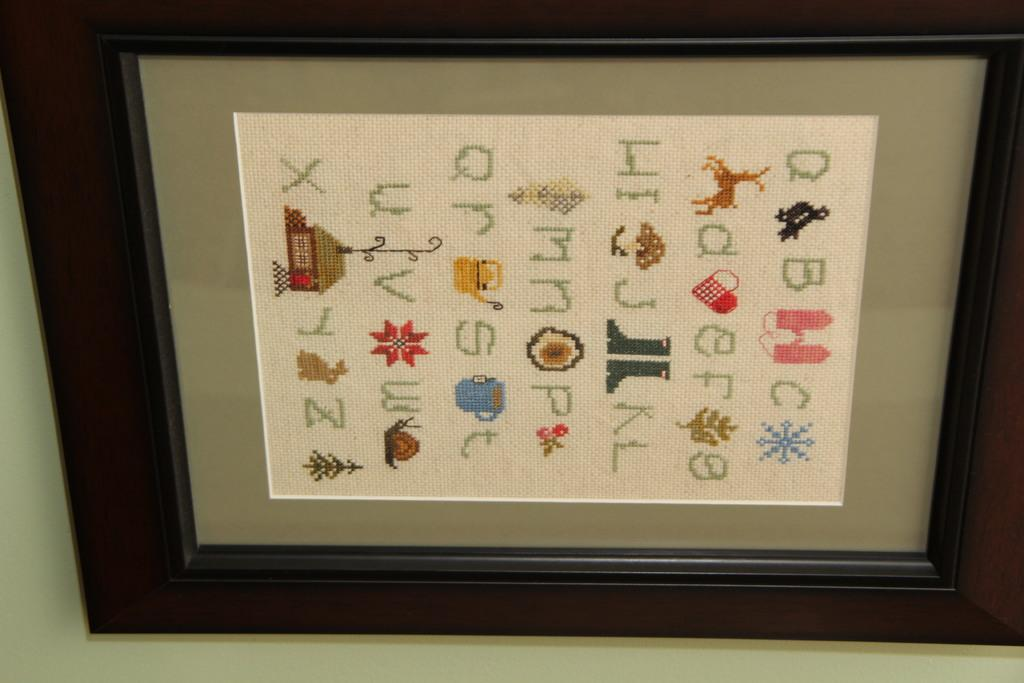<image>
Render a clear and concise summary of the photo. Framed photo that has the alphabets including the letter A in the top right. 